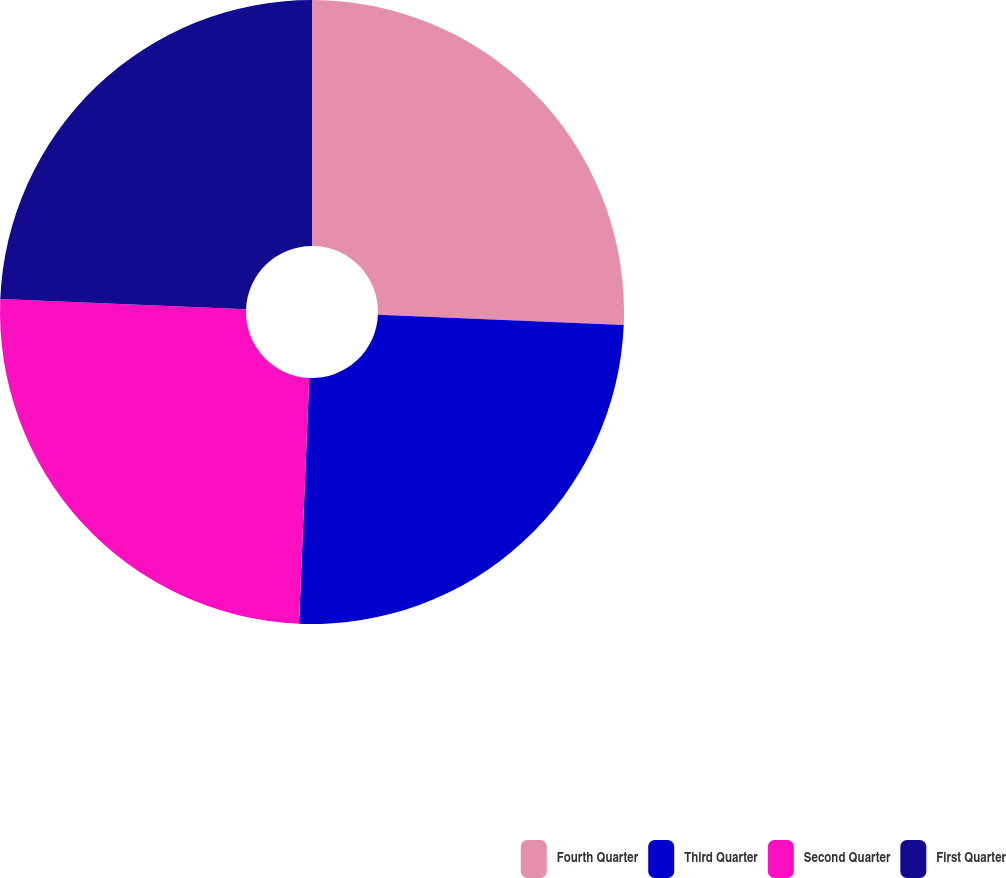<chart> <loc_0><loc_0><loc_500><loc_500><pie_chart><fcel>Fourth Quarter<fcel>Third Quarter<fcel>Second Quarter<fcel>First Quarter<nl><fcel>25.66%<fcel>25.0%<fcel>25.0%<fcel>24.34%<nl></chart> 